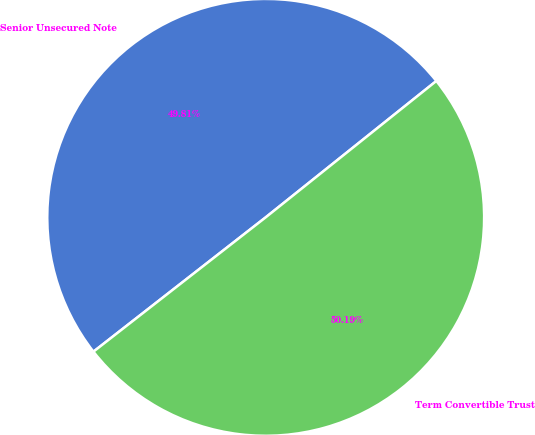<chart> <loc_0><loc_0><loc_500><loc_500><pie_chart><fcel>Senior Unsecured Note<fcel>Term Convertible Trust<nl><fcel>49.81%<fcel>50.19%<nl></chart> 